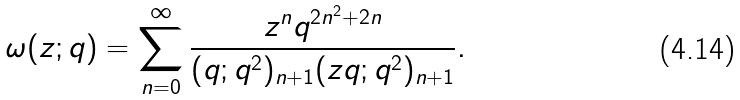<formula> <loc_0><loc_0><loc_500><loc_500>\omega ( z ; q ) = \sum _ { n = 0 } ^ { \infty } \frac { z ^ { n } q ^ { 2 n ^ { 2 } + 2 n } } { ( q ; q ^ { 2 } ) _ { n + 1 } ( z q ; q ^ { 2 } ) _ { n + 1 } } .</formula> 